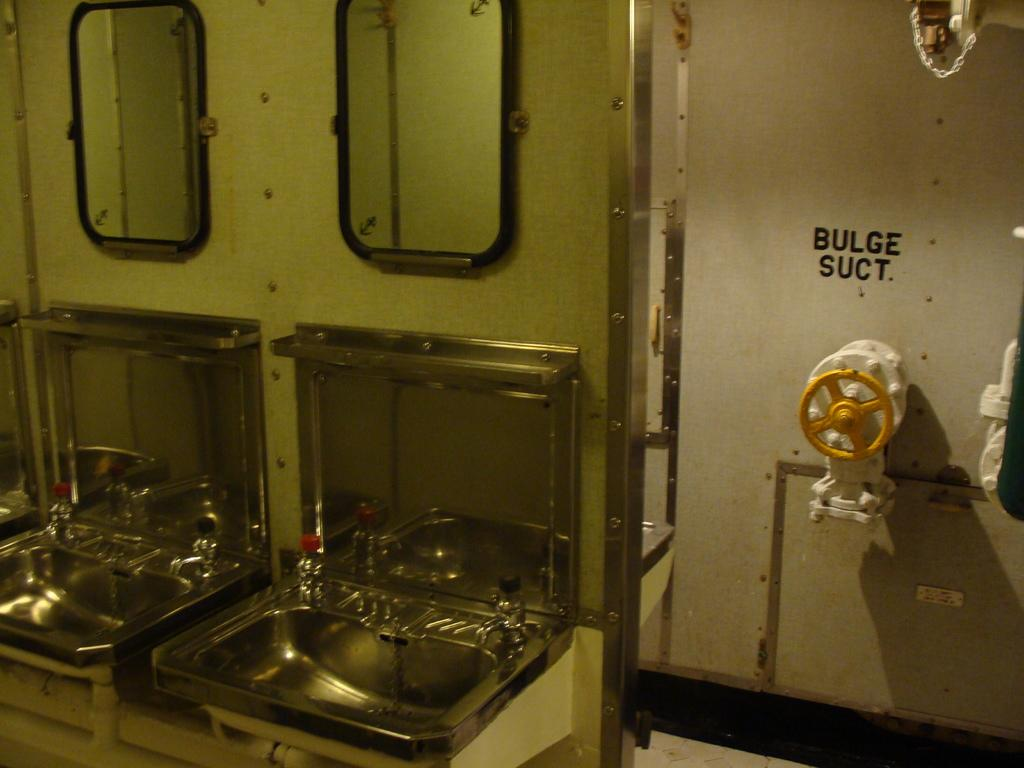<image>
Write a terse but informative summary of the picture. Two sinks and mirrors are seen with the words bulge suct written on the walls. 